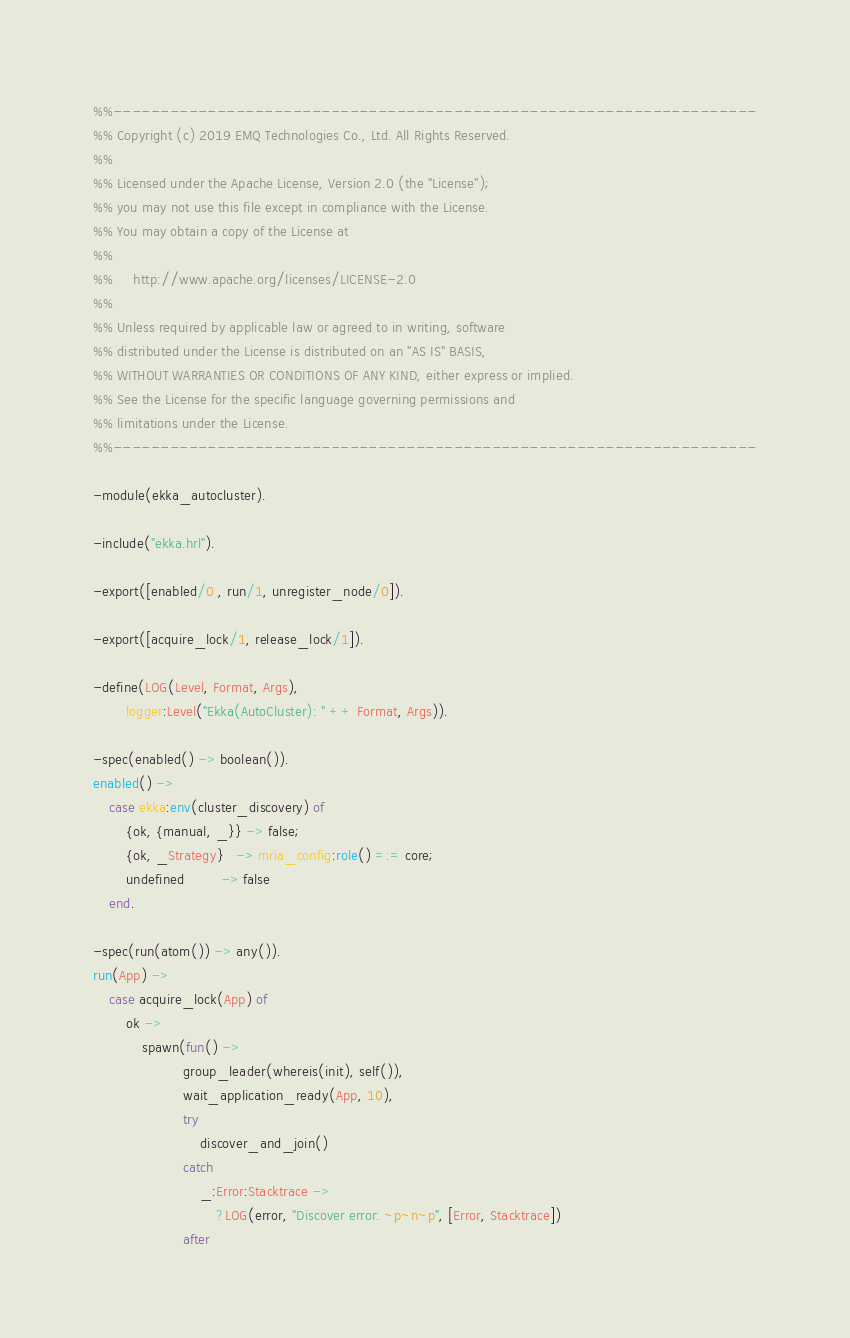<code> <loc_0><loc_0><loc_500><loc_500><_Erlang_>%%--------------------------------------------------------------------
%% Copyright (c) 2019 EMQ Technologies Co., Ltd. All Rights Reserved.
%%
%% Licensed under the Apache License, Version 2.0 (the "License");
%% you may not use this file except in compliance with the License.
%% You may obtain a copy of the License at
%%
%%     http://www.apache.org/licenses/LICENSE-2.0
%%
%% Unless required by applicable law or agreed to in writing, software
%% distributed under the License is distributed on an "AS IS" BASIS,
%% WITHOUT WARRANTIES OR CONDITIONS OF ANY KIND, either express or implied.
%% See the License for the specific language governing permissions and
%% limitations under the License.
%%--------------------------------------------------------------------

-module(ekka_autocluster).

-include("ekka.hrl").

-export([enabled/0 , run/1, unregister_node/0]).

-export([acquire_lock/1, release_lock/1]).

-define(LOG(Level, Format, Args),
        logger:Level("Ekka(AutoCluster): " ++ Format, Args)).

-spec(enabled() -> boolean()).
enabled() ->
    case ekka:env(cluster_discovery) of
        {ok, {manual, _}} -> false;
        {ok, _Strategy}   -> mria_config:role() =:= core;
        undefined         -> false
    end.

-spec(run(atom()) -> any()).
run(App) ->
    case acquire_lock(App) of
        ok ->
            spawn(fun() ->
                      group_leader(whereis(init), self()),
                      wait_application_ready(App, 10),
                      try
                          discover_and_join()
                      catch
                          _:Error:Stacktrace ->
                              ?LOG(error, "Discover error: ~p~n~p", [Error, Stacktrace])
                      after</code> 